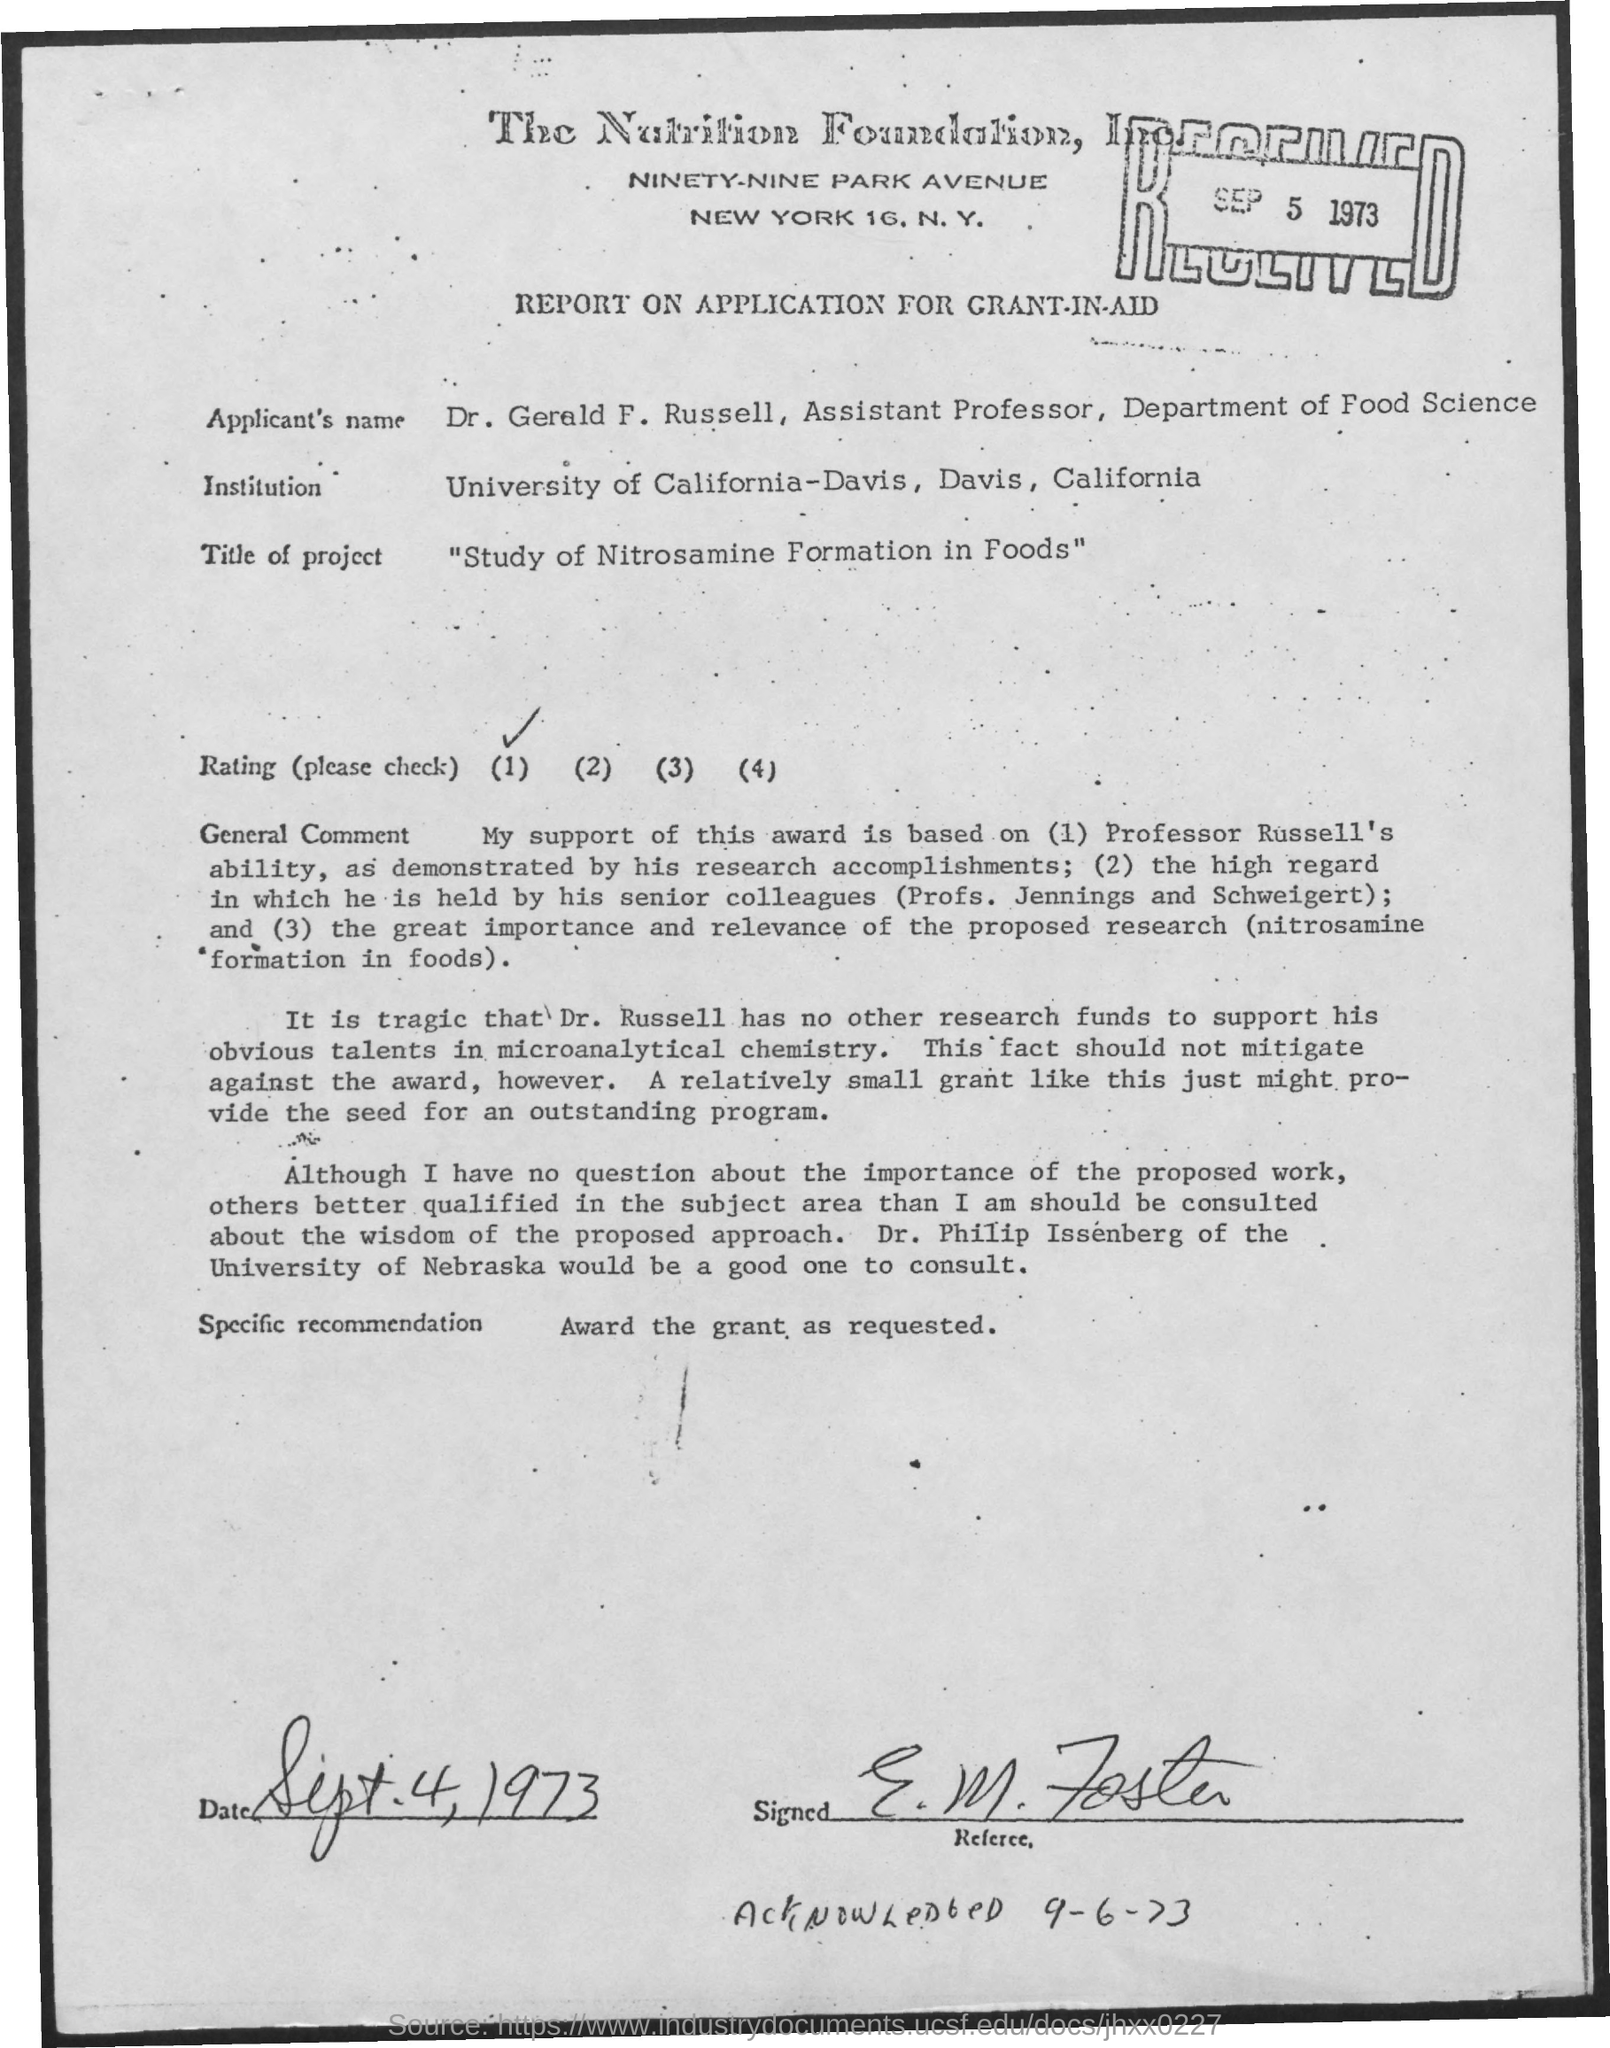What is the date mentioned in the top of the document ?
Keep it short and to the point. SEP 5 1973. What is the Applicant's Name ?
Your response must be concise. Dr. Gerald F. Russell, Assistant Professor, Department of Food Science. What is the Title of the project ?
Provide a short and direct response. "Study of Nitrosamine Formation in Foods". 